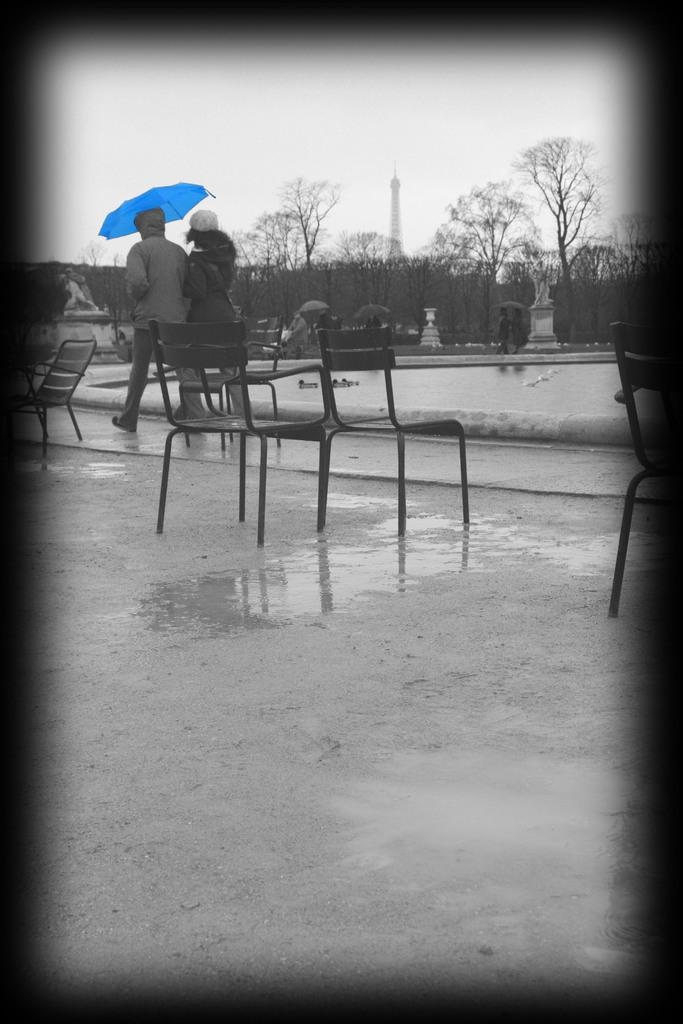What is the condition of the road in the image? The road in the image is wet. What objects are on the wet road? There are chairs on the wet road. What are the two people in the image doing? Two people are walking on the wet road. How are the two people protecting themselves from the weather? The two people are holding an umbrella. What type of underwear is the mother wearing in the image? There is no mother or underwear present in the image. 